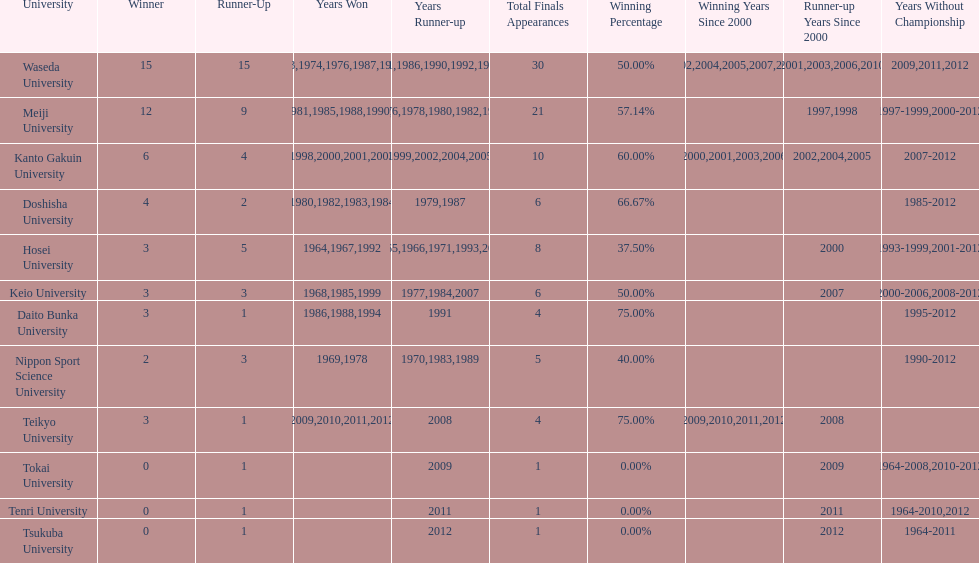Help me parse the entirety of this table. {'header': ['University', 'Winner', 'Runner-Up', 'Years Won', 'Years Runner-up', 'Total Finals Appearances', 'Winning Percentage', 'Winning Years Since 2000', 'Runner-up Years Since 2000', 'Years Without Championship'], 'rows': [['Waseda University', '15', '15', '1965,1966,1968,1970,1971,1973,1974,1976,1987,1989,\\n2002,2004,2005,2007,2008', '1964,1967,1969,1972,1975,1981,1986,1990,1992,1995,\\n1996,2001,2003,2006,2010', '30', '50.00%', '2002,2004,2005,2007,2008', '2001,2003,2006,2010', '2009,2011,2012'], ['Meiji University', '12', '9', '1972,1975,1977,1979,1981,1985,1988,1990,1991,1993,\\n1995,1996', '1973,1974,1976,1978,1980,1982,1994,1997,1998', '21', '57.14%', '', '1997,1998', '1997-1999,2000-2012'], ['Kanto Gakuin University', '6', '4', '1997,1998,2000,2001,2003,2006', '1999,2002,2004,2005', '10', '60.00%', '2000,2001,2003,2006', '2002,2004,2005', '2007-2012'], ['Doshisha University', '4', '2', '1980,1982,1983,1984', '1979,1987', '6', '66.67%', '', '', '1985-2012'], ['Hosei University', '3', '5', '1964,1967,1992', '1965,1966,1971,1993,2000', '8', '37.50%', '', '2000', '1993-1999,2001-2012'], ['Keio University', '3', '3', '1968,1985,1999', '1977,1984,2007', '6', '50.00%', '', '2007', '2000-2006,2008-2012'], ['Daito Bunka University', '3', '1', '1986,1988,1994', '1991', '4', '75.00%', '', '', '1995-2012'], ['Nippon Sport Science University', '2', '3', '1969,1978', '1970,1983,1989', '5', '40.00%', '', '', '1990-2012'], ['Teikyo University', '3', '1', '2009,2010,2011,2012', '2008', '4', '75.00%', '2009,2010,2011,2012', '2008', ''], ['Tokai University', '0', '1', '', '2009', '1', '0.00%', '', '2009', '1964-2008,2010-2012'], ['Tenri University', '0', '1', '', '2011', '1', '0.00%', '', '2011', '1964-2010,2012'], ['Tsukuba University', '0', '1', '', '2012', '1', '0.00%', '', '2012', '1964-2011']]} Which universities had a number of wins higher than 12? Waseda University. 